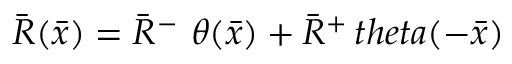<formula> <loc_0><loc_0><loc_500><loc_500>{ \bar { R } } ( { \bar { x } } ) = { \bar { R } } ^ { - } \ \theta ( { \bar { x } } ) + { \bar { R } } ^ { + } \, t h e t a ( - { \bar { x } } )</formula> 